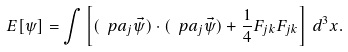Convert formula to latex. <formula><loc_0><loc_0><loc_500><loc_500>E [ \psi ] = \int \left [ ( \ p a _ { j } \vec { \psi } ) \cdot ( \ p a _ { j } \vec { \psi } ) + \frac { 1 } { 4 } F _ { j k } F _ { j k } \right ] \, d ^ { 3 } x .</formula> 